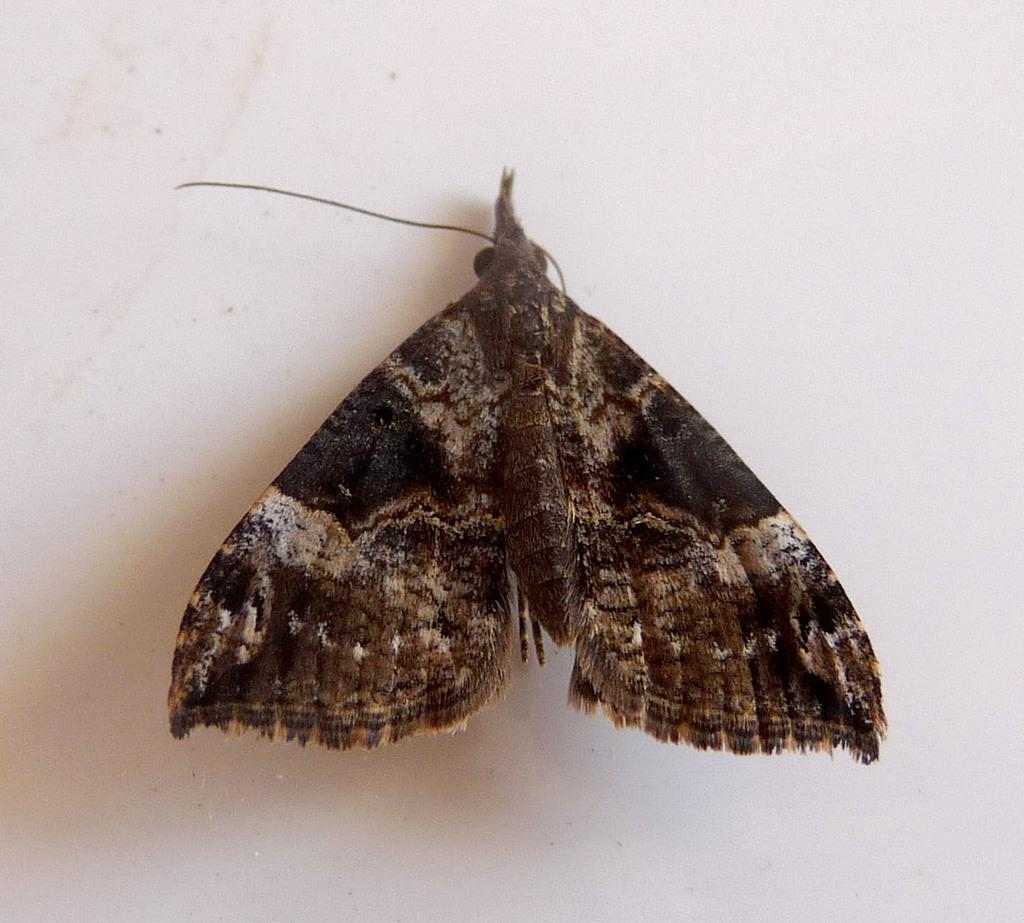What type of insect is in the image? There is a moth in the image. Where is the moth located in relation to the image? The moth is in the front of the image. What can be seen in the background of the image? There is a wall in the background of the image. What type of selection is available for the moth to choose from in the image? There is no selection available for the moth to choose from in the image, as it is a still photograph. 